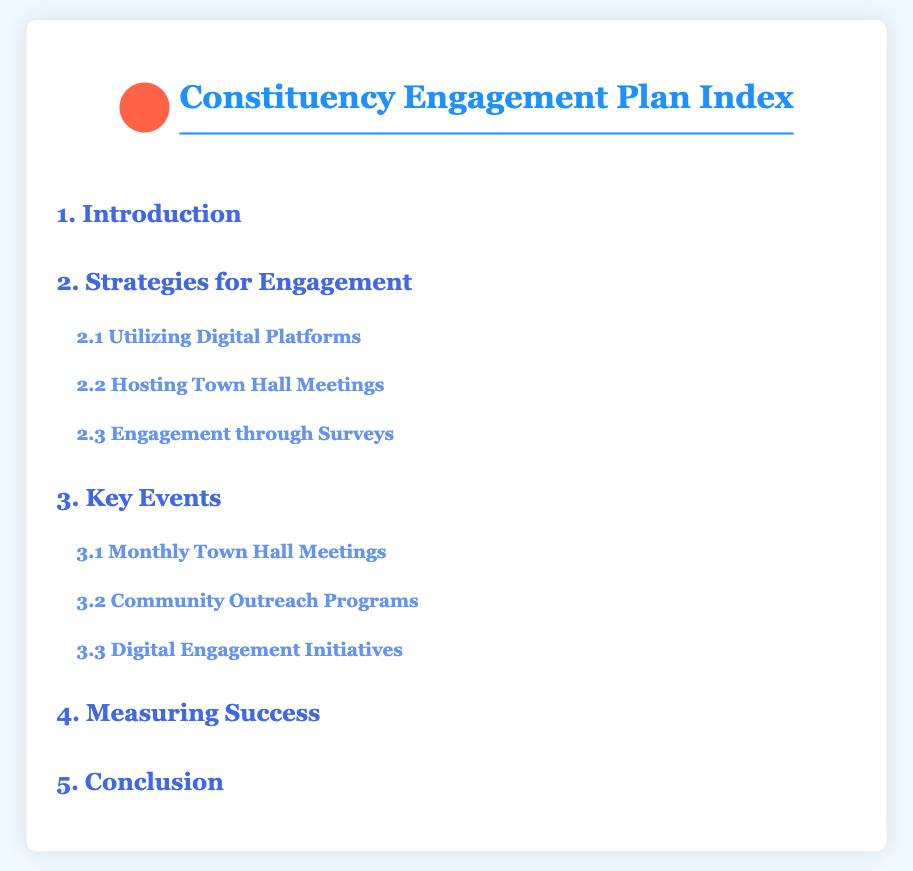What is the title of the Index? The title is found at the top of the document, stating the subject of the document.
Answer: Constituency Engagement Plan Index How many main sections are in the document? The document features major categorizations, which can be counted as distinct sections listed in the Index.
Answer: Five What topic is covered under section 2.1? This section specifically addresses a method of engaging constituents mentioned in the document.
Answer: Utilizing Digital Platforms Name one type of event listed in section 3. This section highlights various planned initiatives for engaging with the community, with different types of events mentioned.
Answer: Monthly Town Hall Meetings What is the purpose of the Constituency Engagement Plan? The title and introduction suggest the document's purpose focuses on enhancing communication and interaction with constituents.
Answer: Enhance communication and interaction What is the color of the header text? The document indicates the color used for the titles and headings within it.
Answer: #1e90ff How are the index items styled when hovered over? The document specifies how the cursor interacts with the index items, enhancing user experience.
Answer: Changes color and moves right What follows the Strategies for Engagement section? The sections are ordered sequentially in the document, outlining the content structure.
Answer: Key Events 